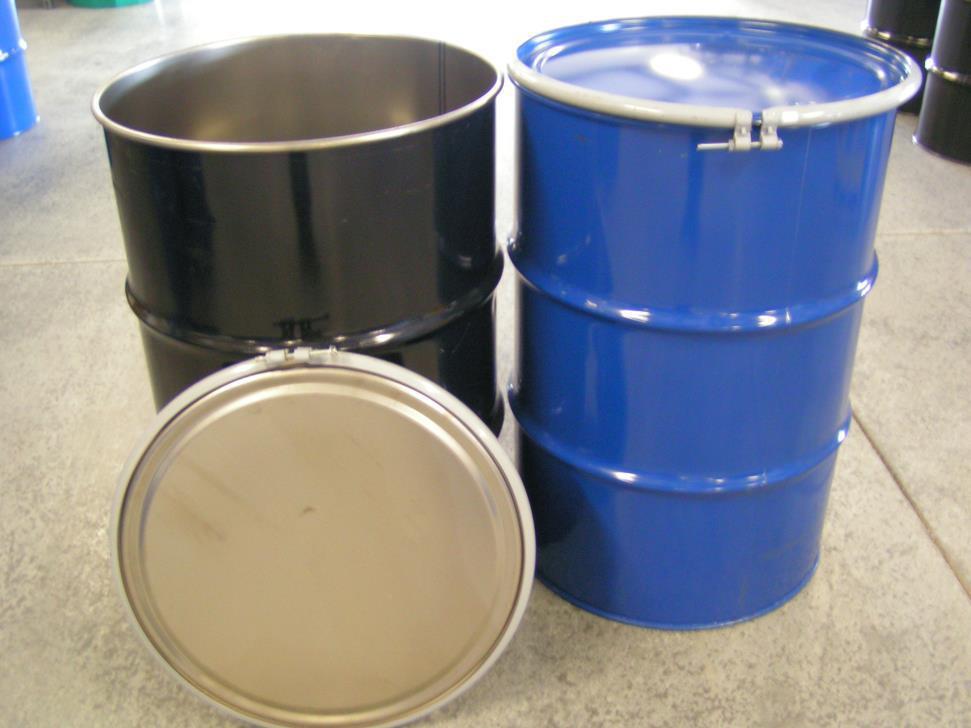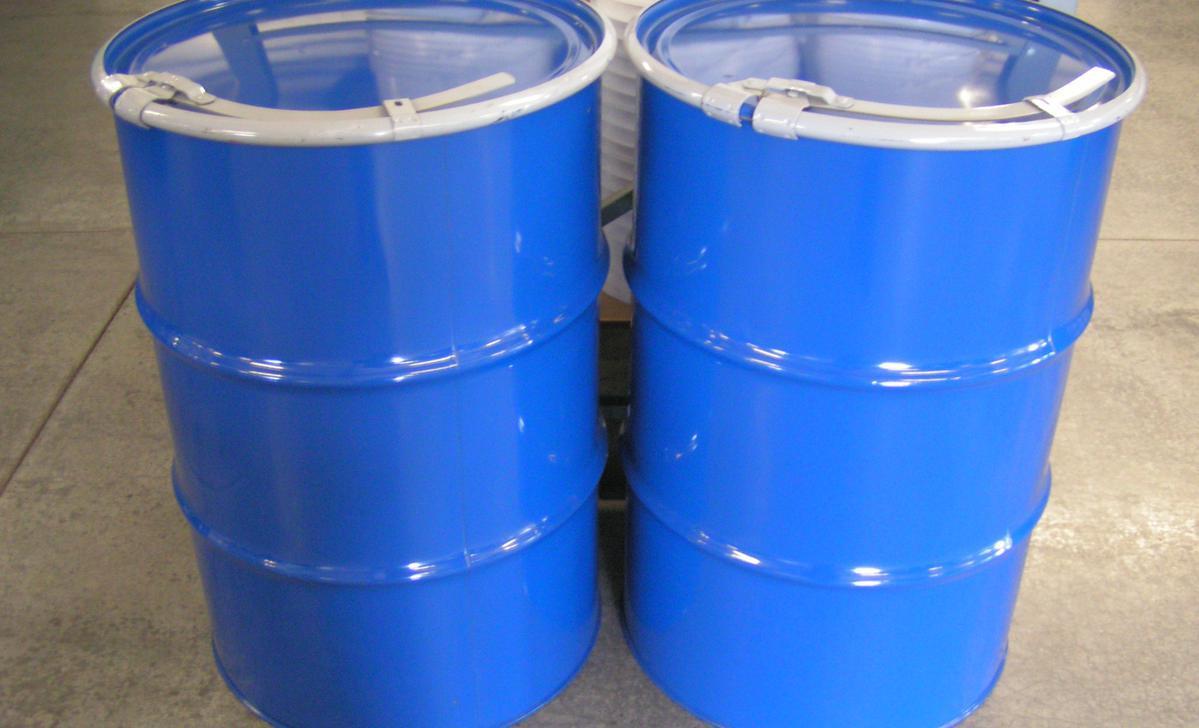The first image is the image on the left, the second image is the image on the right. For the images displayed, is the sentence "One image shows a barrel with a yellow end being hoisted by a blue lift that grips either end and is attached to a hook." factually correct? Answer yes or no. No. The first image is the image on the left, the second image is the image on the right. For the images shown, is this caption "The barrels in the images are hanging horizontally." true? Answer yes or no. No. 